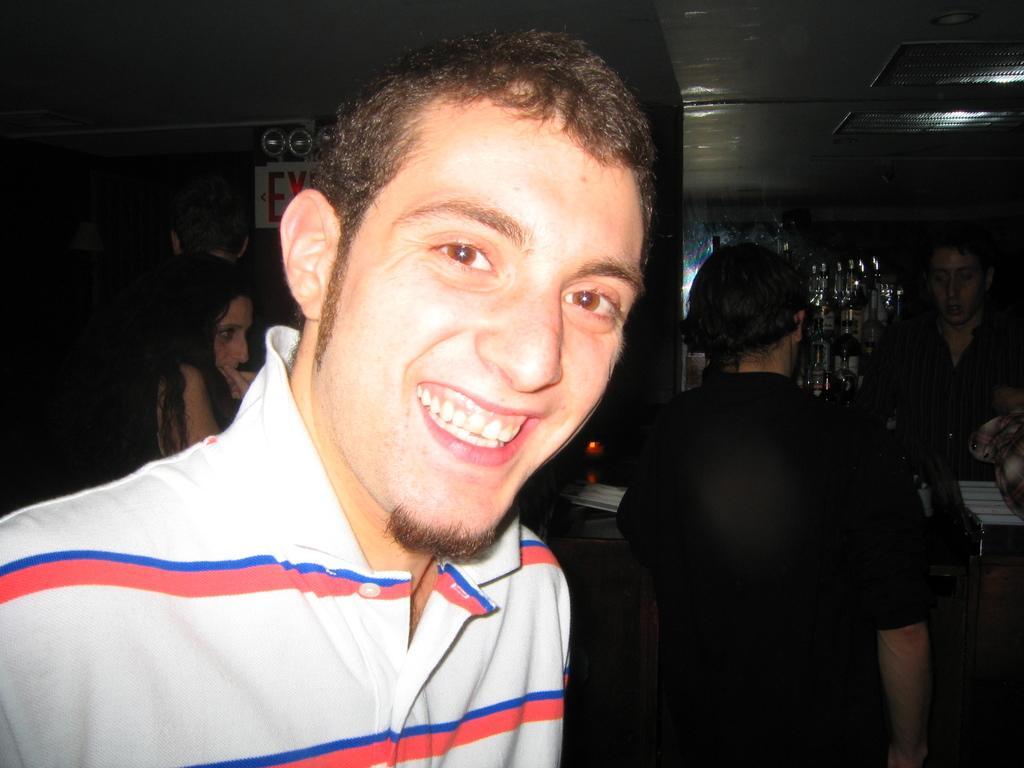How would you summarize this image in a sentence or two? On the left side of this image I can see a person wearing a white color t-shirt, smiling and giving pose for the picture. In the background, I can see some more people and few bottles in the dark. 